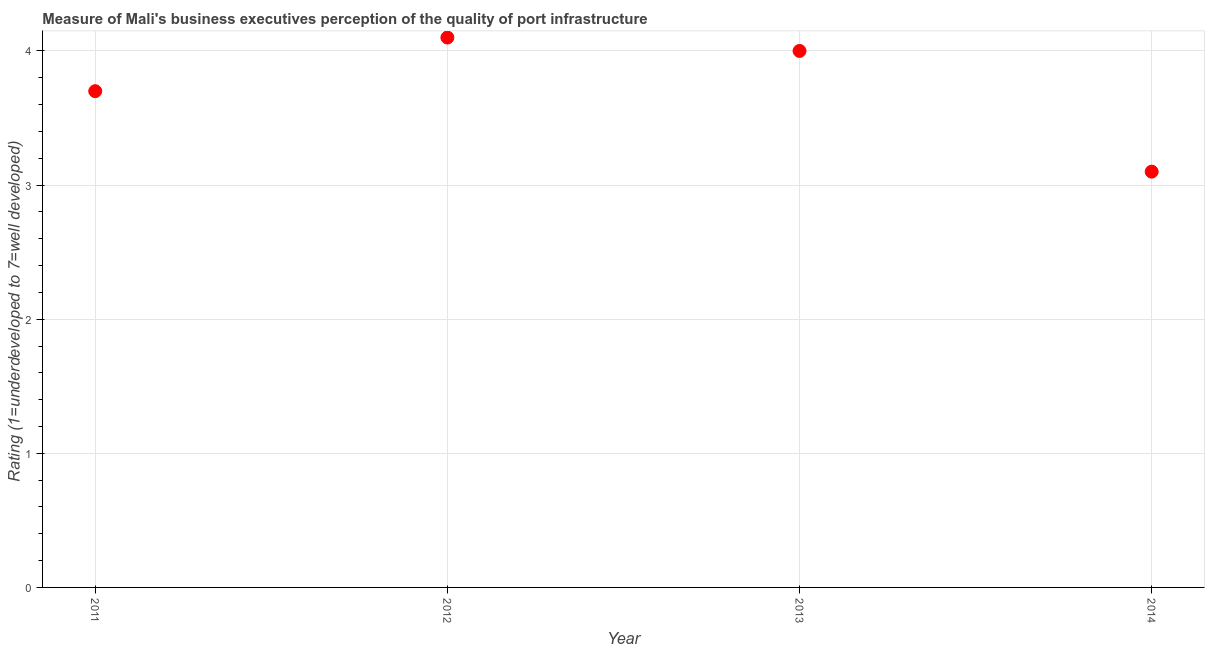What is the rating measuring quality of port infrastructure in 2011?
Make the answer very short. 3.7. Across all years, what is the maximum rating measuring quality of port infrastructure?
Give a very brief answer. 4.1. Across all years, what is the minimum rating measuring quality of port infrastructure?
Make the answer very short. 3.1. In which year was the rating measuring quality of port infrastructure minimum?
Give a very brief answer. 2014. What is the sum of the rating measuring quality of port infrastructure?
Your response must be concise. 14.9. What is the difference between the rating measuring quality of port infrastructure in 2011 and 2012?
Offer a very short reply. -0.4. What is the average rating measuring quality of port infrastructure per year?
Provide a short and direct response. 3.73. What is the median rating measuring quality of port infrastructure?
Your response must be concise. 3.85. In how many years, is the rating measuring quality of port infrastructure greater than 1.2 ?
Ensure brevity in your answer.  4. What is the ratio of the rating measuring quality of port infrastructure in 2011 to that in 2014?
Give a very brief answer. 1.19. What is the difference between the highest and the second highest rating measuring quality of port infrastructure?
Offer a terse response. 0.1. What is the difference between the highest and the lowest rating measuring quality of port infrastructure?
Give a very brief answer. 1. In how many years, is the rating measuring quality of port infrastructure greater than the average rating measuring quality of port infrastructure taken over all years?
Keep it short and to the point. 2. Are the values on the major ticks of Y-axis written in scientific E-notation?
Your answer should be compact. No. What is the title of the graph?
Ensure brevity in your answer.  Measure of Mali's business executives perception of the quality of port infrastructure. What is the label or title of the X-axis?
Keep it short and to the point. Year. What is the label or title of the Y-axis?
Keep it short and to the point. Rating (1=underdeveloped to 7=well developed) . What is the difference between the Rating (1=underdeveloped to 7=well developed)  in 2011 and 2012?
Your answer should be very brief. -0.4. What is the difference between the Rating (1=underdeveloped to 7=well developed)  in 2011 and 2014?
Keep it short and to the point. 0.6. What is the difference between the Rating (1=underdeveloped to 7=well developed)  in 2012 and 2013?
Ensure brevity in your answer.  0.1. What is the difference between the Rating (1=underdeveloped to 7=well developed)  in 2012 and 2014?
Provide a succinct answer. 1. What is the ratio of the Rating (1=underdeveloped to 7=well developed)  in 2011 to that in 2012?
Your answer should be compact. 0.9. What is the ratio of the Rating (1=underdeveloped to 7=well developed)  in 2011 to that in 2013?
Offer a very short reply. 0.93. What is the ratio of the Rating (1=underdeveloped to 7=well developed)  in 2011 to that in 2014?
Your answer should be very brief. 1.19. What is the ratio of the Rating (1=underdeveloped to 7=well developed)  in 2012 to that in 2013?
Your response must be concise. 1.02. What is the ratio of the Rating (1=underdeveloped to 7=well developed)  in 2012 to that in 2014?
Offer a very short reply. 1.32. What is the ratio of the Rating (1=underdeveloped to 7=well developed)  in 2013 to that in 2014?
Make the answer very short. 1.29. 